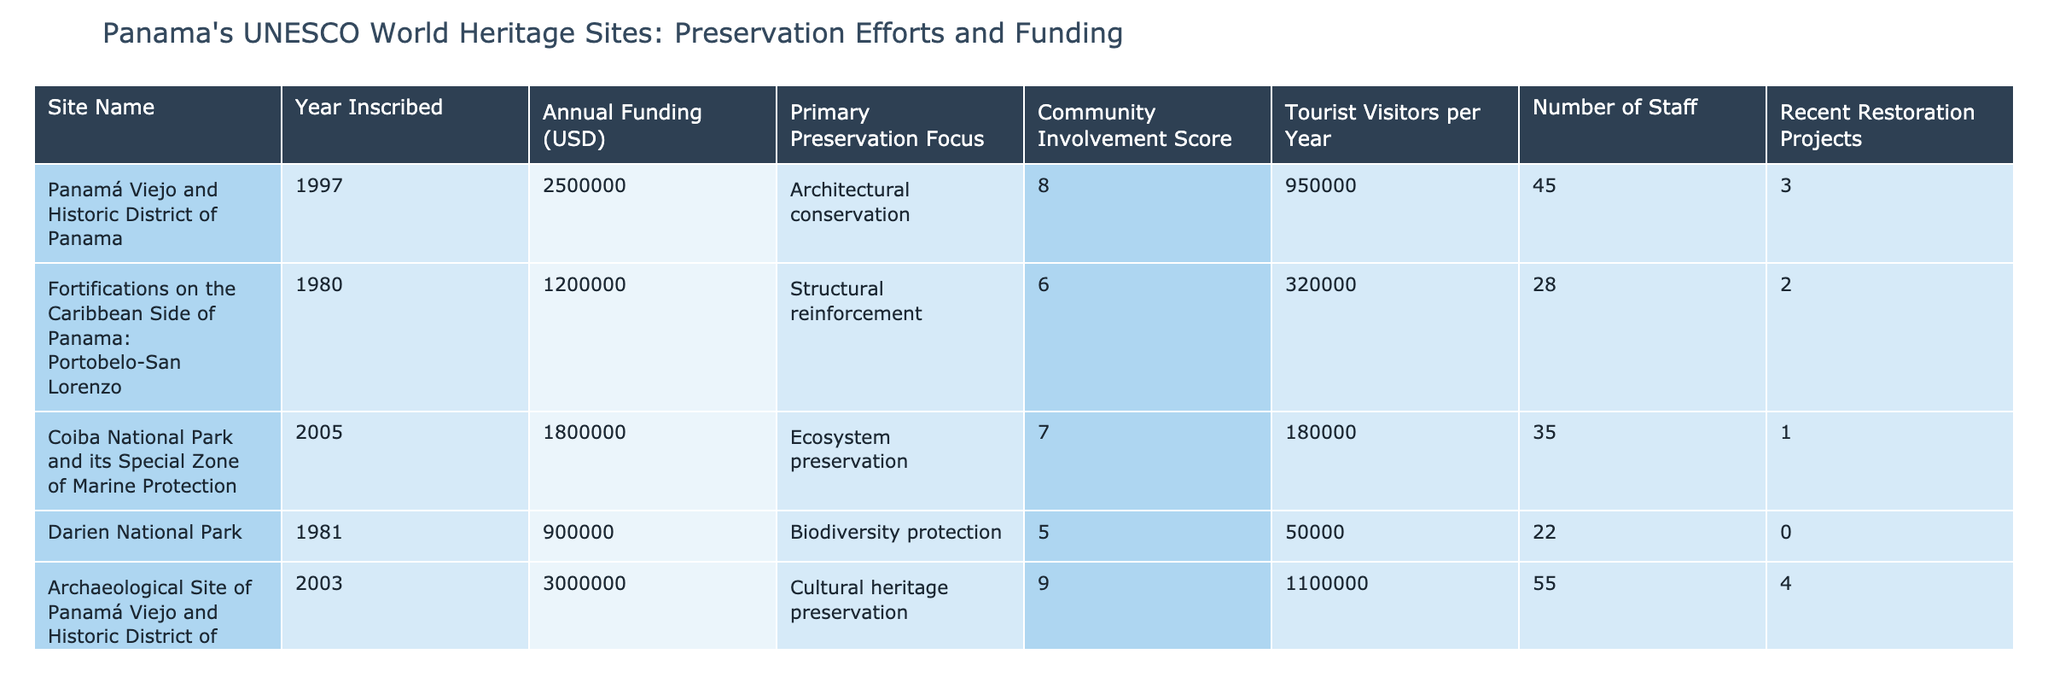What is the highest annual funding allocated to a UNESCO World Heritage Site in Panama? By examining the 'Annual Funding (USD)' column, we see that the site with the highest funding is 'Archaeological Site of Panamá Viejo and Historic District of Panamá' with 3,000,000 USD.
Answer: 3,000,000 USD Which site has the most tourist visitors per year? Looking at the 'Tourist Visitors per Year' column, 'Archaeological Site of Panamá Viejo and Historic District of Panamá' has the highest figure with 1,100,000 visitors.
Answer: 1,100,000 visitors Is the 'Darien National Park' funding higher than 'Fortifications on the Caribbean Side of Panama: Portobelo-San Lorenzo'? Comparing the 'Annual Funding (USD)' values, 'Darien National Park' has 900,000 USD while 'Fortifications on the Caribbean Side of Panama: Portobelo-San Lorenzo' has 1,200,000 USD. Since 900,000 is less than 1,200,000, the statement is false.
Answer: No Calculate the total annual funding for all the UNESCO World Heritage Sites listed. The annual funding values are 2,500,000 + 1,200,000 + 1,800,000 + 900,000 + 3,000,000 + 1,500,000, which sums up to 11,900,000 USD.
Answer: 11,900,000 USD Which site has the highest community involvement score, and what is that score? The 'Community Involvement Score' column shows that 'Archaeological Site of Panamá Viejo and Historic District of Panamá' has the highest score of 9.
Answer: 9 What is the average number of staff across all sites? The number of staff are 45, 28, 35, 22, 55, and 30; summing these gives 215. There are 6 sites, so the average is 215 divided by 6, which equals approximately 35.83.
Answer: 35.83 Does 'Coiba National Park and its Special Zone of Marine Protection' have a lower community involvement score than 'Fortifications on the Caribbean Side of Panama: Portobelo-San Lorenzo'? 'Coiba National Park' has a community involvement score of 7 while 'Fortifications' has a score of 6. Since 7 is greater than 6, the statement is false.
Answer: No How many restoration projects have been completed in total across all the sites? By adding the 'Recent Restoration Projects' values: 3 + 2 + 1 + 0 + 4 + 1, we find the total is 11 restoration projects completed.
Answer: 11 